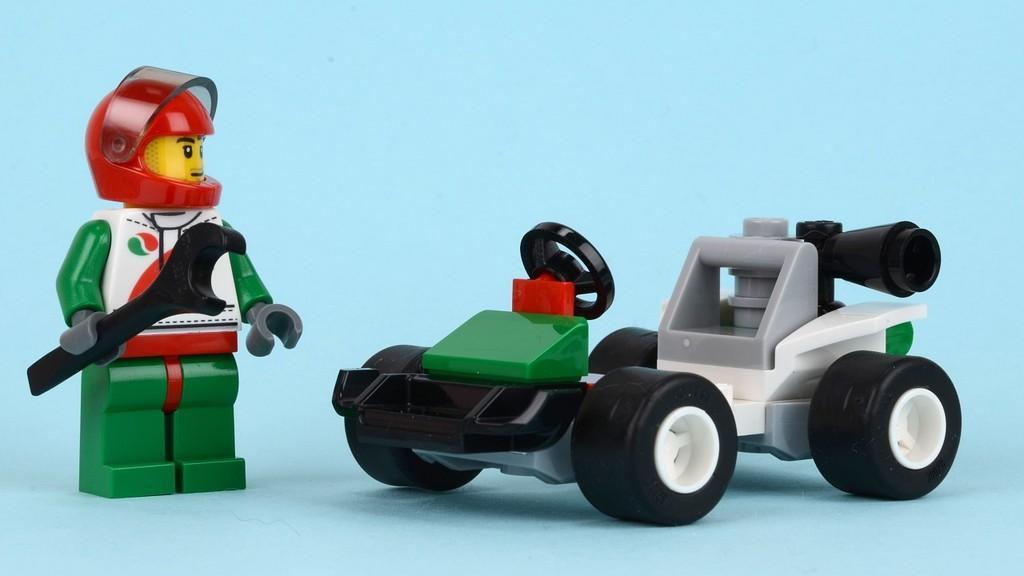Could you give a brief overview of what you see in this image? in the image i can see two toys and the background is blue. 